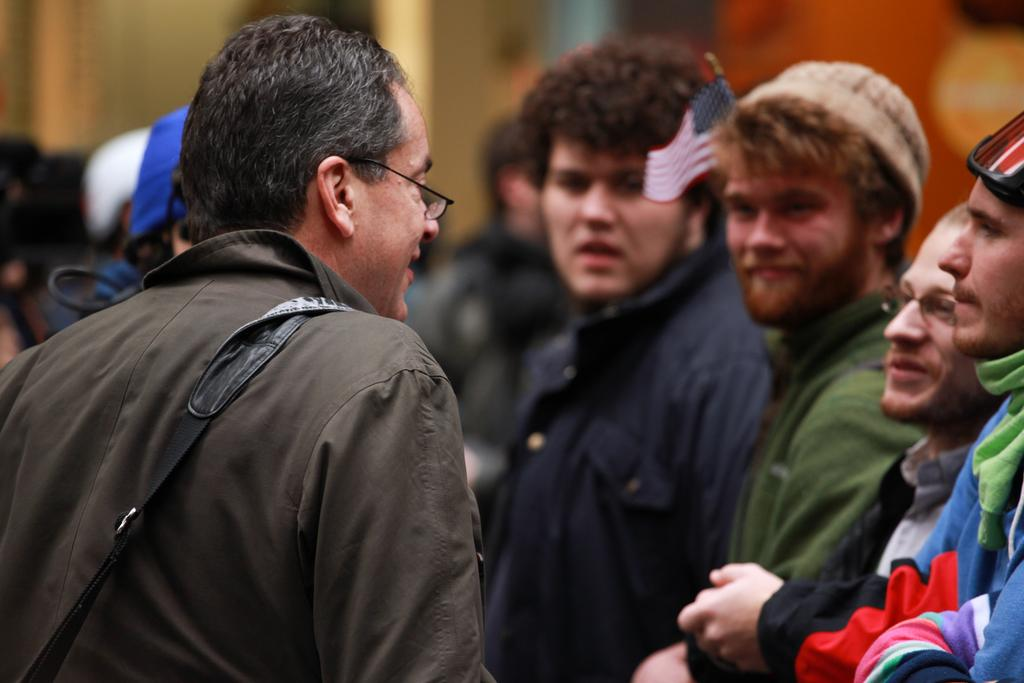Who is present in the image? There is a man in the image. What is the man wearing? The man is wearing glasses. What can be seen on the left side of the image? There is a bag on the left side of the image. What is visible on the right side of the image? There are people on the right side of the image. Can you describe the background of the image? The background is not clear. How many cents are visible on the man's head in the image? There are no cents visible on the man's head in the image. What type of van is parked behind the people on the right side of the image? There is no van present in the image. 